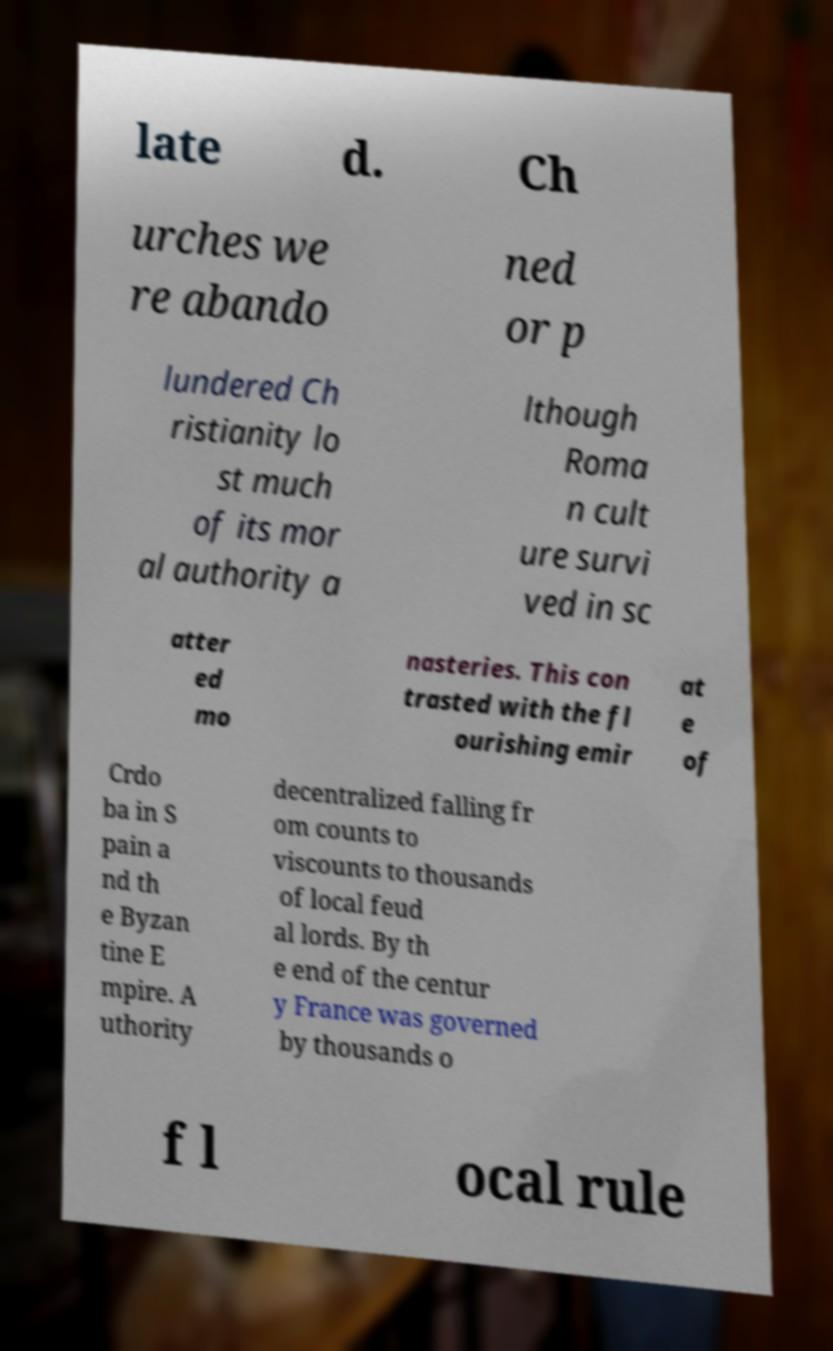Could you extract and type out the text from this image? late d. Ch urches we re abando ned or p lundered Ch ristianity lo st much of its mor al authority a lthough Roma n cult ure survi ved in sc atter ed mo nasteries. This con trasted with the fl ourishing emir at e of Crdo ba in S pain a nd th e Byzan tine E mpire. A uthority decentralized falling fr om counts to viscounts to thousands of local feud al lords. By th e end of the centur y France was governed by thousands o f l ocal rule 